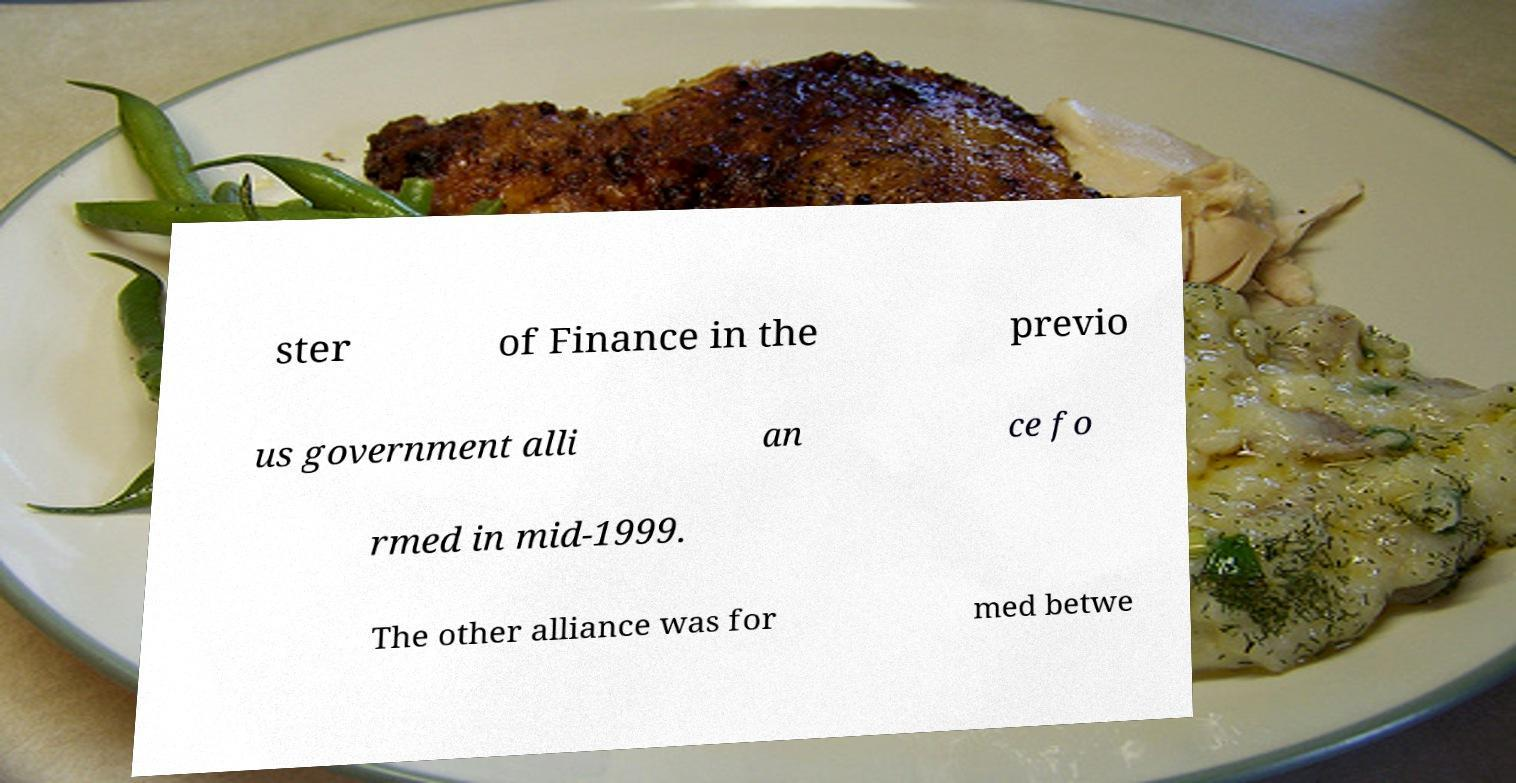For documentation purposes, I need the text within this image transcribed. Could you provide that? ster of Finance in the previo us government alli an ce fo rmed in mid-1999. The other alliance was for med betwe 